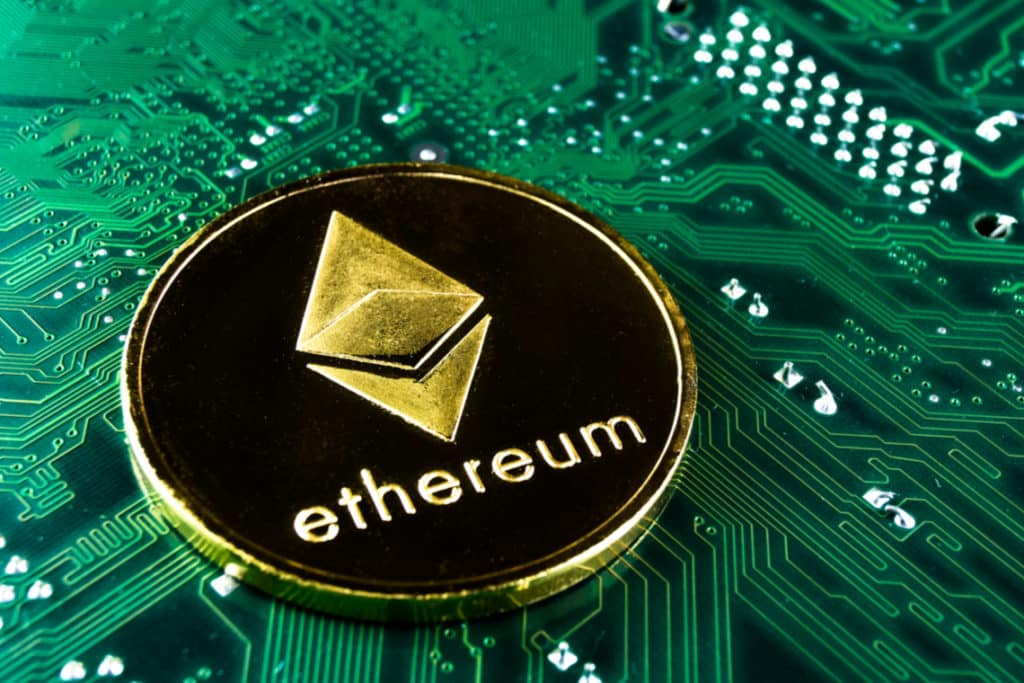How does the image emphasize the role of hardware in cryptocurrency mining? The image highlights the critical role of hardware in cryptocurrency mining by juxtaposing a symbolic Ethereum coin with a detailed view of a circuit board. This visual representation underscores that cryptocurrency mining is not merely a digital or software process but heavily depends on the physical infrastructure of computing hardware. The complexity of the circuit board reflects the sophisticated technology required for mining operations, emphasizing the energy and computational power necessary to validate transactions and secure the blockchain network. 